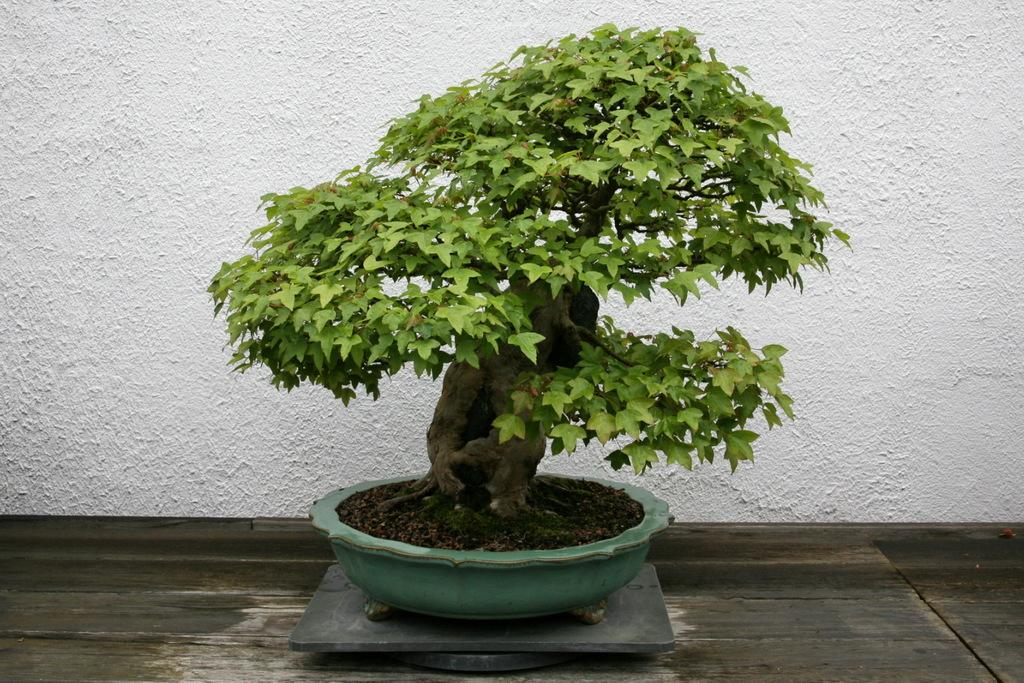What is the color of the wall in the image? The wall in the image is white. What type of plant can be seen in the image? There is a bonsai in the image. What is the bonsai placed in? There is a pot in the image where the bonsai is placed. Can you see a rose in the image? No, there is no rose present in the image. Is there a sister in the image? There is no person, including a sister, present in the image. 